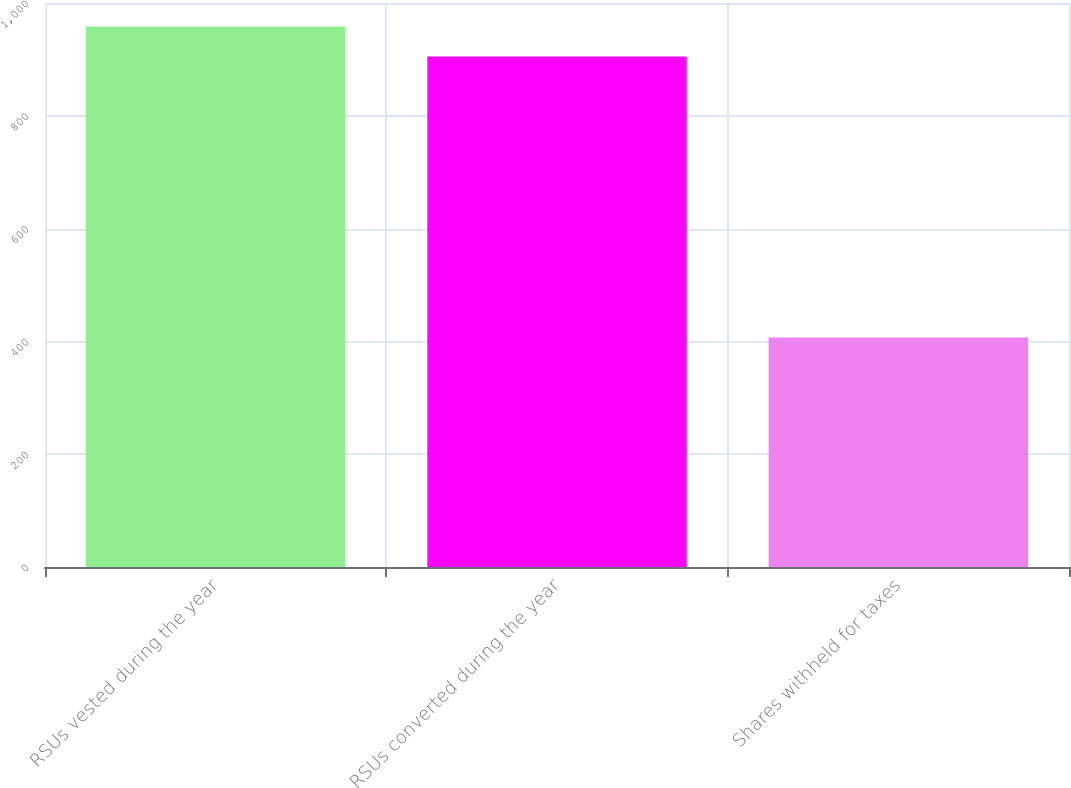Convert chart to OTSL. <chart><loc_0><loc_0><loc_500><loc_500><bar_chart><fcel>RSUs vested during the year<fcel>RSUs converted during the year<fcel>Shares withheld for taxes<nl><fcel>958.5<fcel>905<fcel>407<nl></chart> 